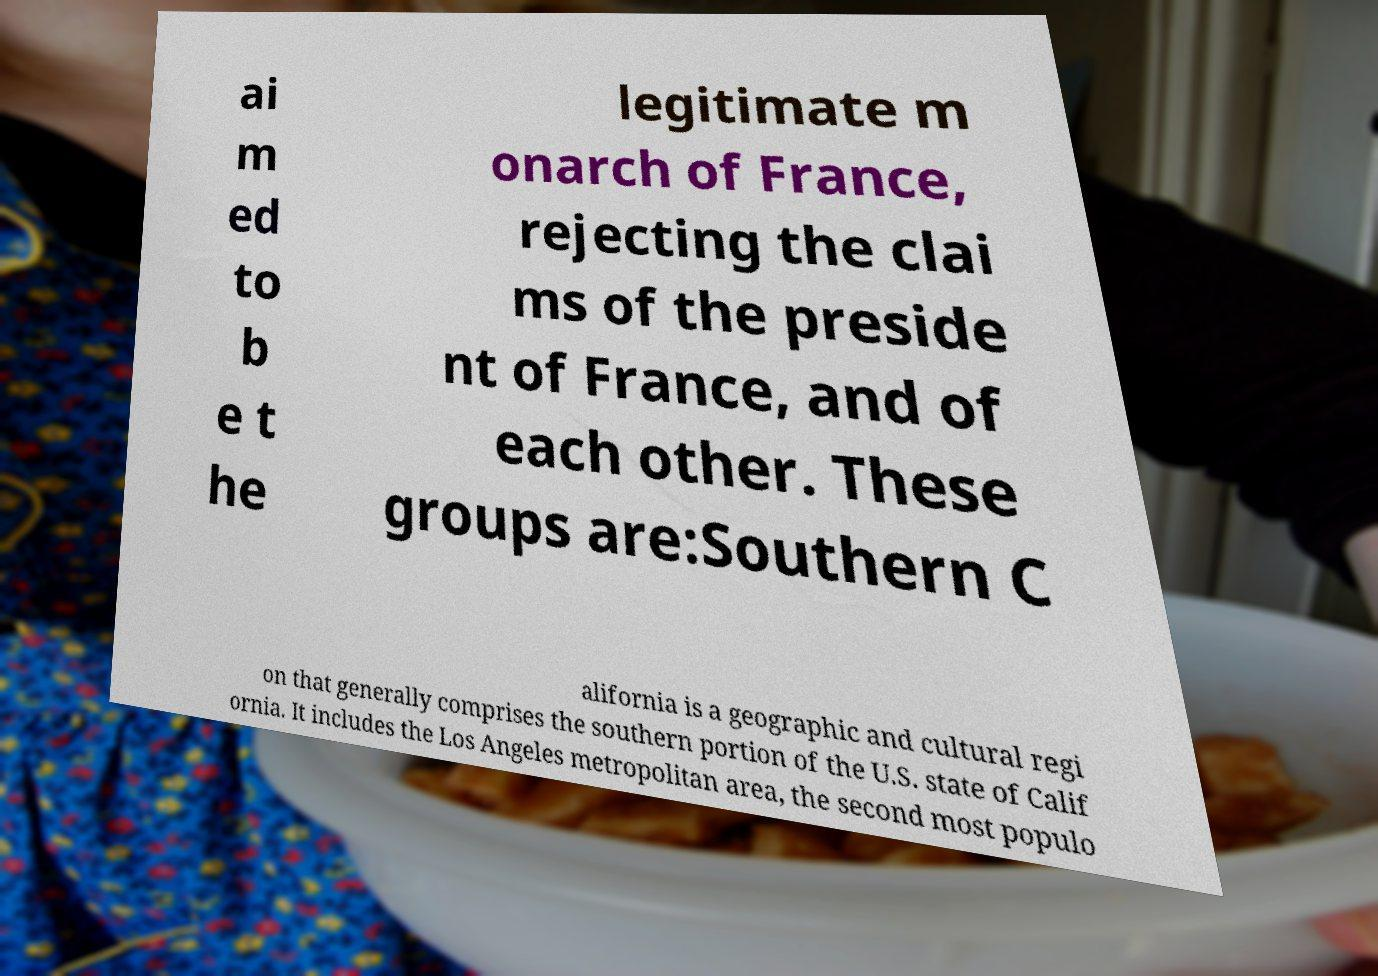Could you assist in decoding the text presented in this image and type it out clearly? ai m ed to b e t he legitimate m onarch of France, rejecting the clai ms of the preside nt of France, and of each other. These groups are:Southern C alifornia is a geographic and cultural regi on that generally comprises the southern portion of the U.S. state of Calif ornia. It includes the Los Angeles metropolitan area, the second most populo 